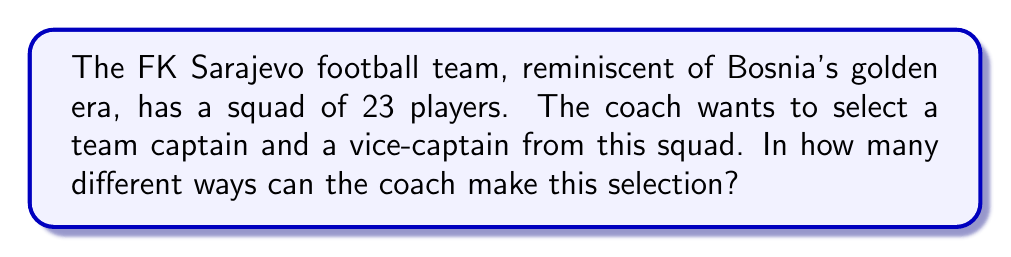Give your solution to this math problem. Let's approach this step-by-step:

1) We need to select two positions: captain and vice-captain.

2) For the captain's position, we have 23 players to choose from. This is our first selection.

3) After selecting the captain, we have 22 players left to choose from for the vice-captain position. This is our second selection.

4) This scenario fits the multiplication principle of counting. We multiply the number of ways to make each selection.

5) The number of ways to make these selections can be calculated as:
   
   $$ 23 \times 22 = 506 $$

6) However, this calculation assumes that the order of selection matters (i.e., selecting Player A as captain and Player B as vice-captain is different from selecting Player B as captain and Player A as vice-captain).

7) In mathematical terms, this is a permutation of 2 players from a group of 23, denoted as $P(23,2)$.

8) The formula for this permutation is:

   $$ P(23,2) = \frac{23!}{(23-2)!} = \frac{23!}{21!} = 23 \times 22 = 506 $$

Therefore, there are 506 different ways to select a team captain and vice-captain from the FK Sarajevo squad.
Answer: 506 ways 